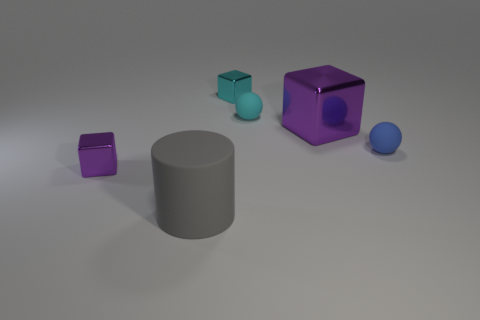What material is the other block that is the same color as the large block?
Your response must be concise. Metal. There is a tiny cyan thing that is the same shape as the tiny blue rubber thing; what is its material?
Your answer should be compact. Rubber. Do the big cylinder and the large block have the same color?
Your response must be concise. No. How many purple things are either balls or small shiny objects?
Your response must be concise. 1. Are there any tiny spheres in front of the blue ball?
Give a very brief answer. No. What size is the blue matte thing?
Your answer should be compact. Small. What is the size of the other object that is the same shape as the small blue rubber object?
Offer a very short reply. Small. How many rubber balls are to the right of the cylinder in front of the large purple block?
Offer a very short reply. 2. Does the purple cube to the right of the cyan shiny cube have the same material as the block that is on the left side of the big gray matte thing?
Ensure brevity in your answer.  Yes. What number of purple things have the same shape as the cyan metallic thing?
Ensure brevity in your answer.  2. 